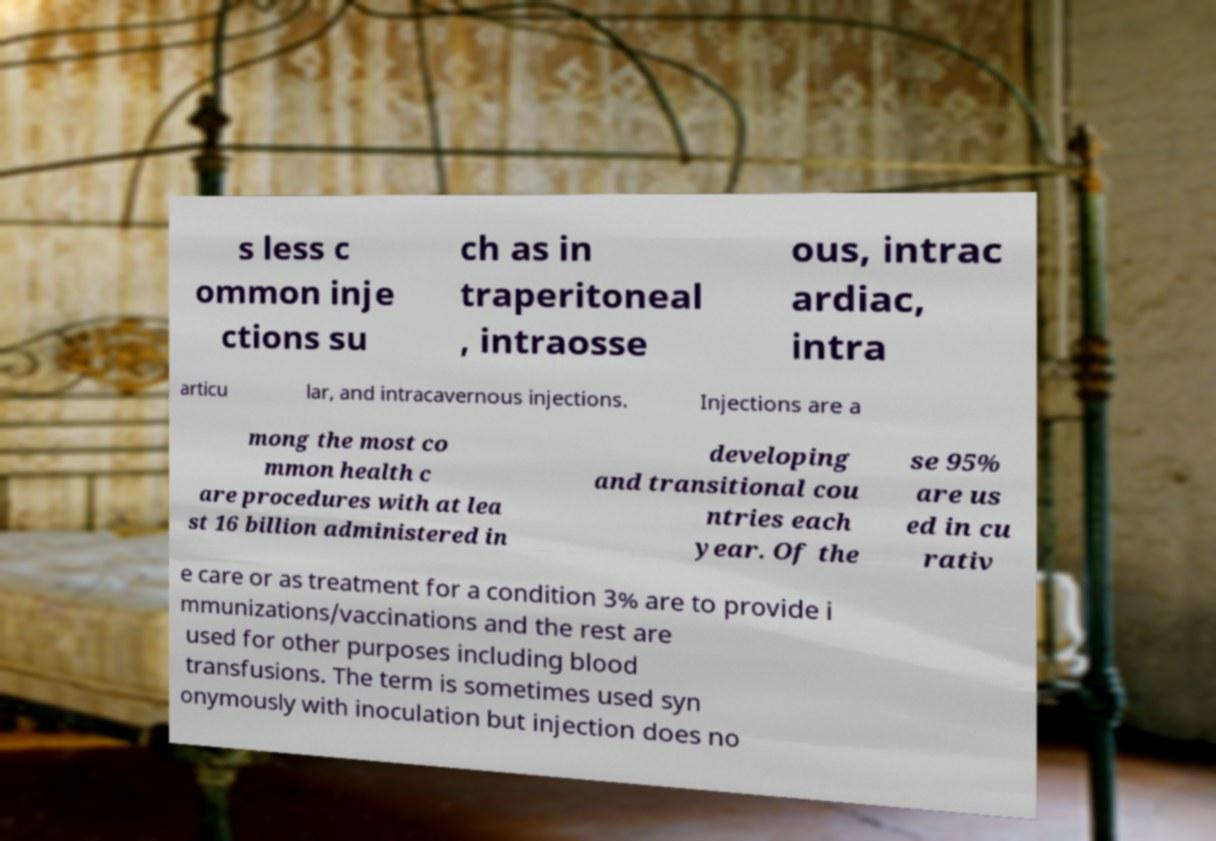Could you extract and type out the text from this image? s less c ommon inje ctions su ch as in traperitoneal , intraosse ous, intrac ardiac, intra articu lar, and intracavernous injections. Injections are a mong the most co mmon health c are procedures with at lea st 16 billion administered in developing and transitional cou ntries each year. Of the se 95% are us ed in cu rativ e care or as treatment for a condition 3% are to provide i mmunizations/vaccinations and the rest are used for other purposes including blood transfusions. The term is sometimes used syn onymously with inoculation but injection does no 